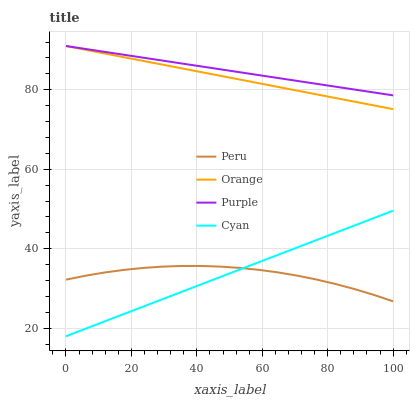Does Peru have the minimum area under the curve?
Answer yes or no. Yes. Does Purple have the maximum area under the curve?
Answer yes or no. Yes. Does Purple have the minimum area under the curve?
Answer yes or no. No. Does Peru have the maximum area under the curve?
Answer yes or no. No. Is Cyan the smoothest?
Answer yes or no. Yes. Is Peru the roughest?
Answer yes or no. Yes. Is Purple the smoothest?
Answer yes or no. No. Is Purple the roughest?
Answer yes or no. No. Does Cyan have the lowest value?
Answer yes or no. Yes. Does Peru have the lowest value?
Answer yes or no. No. Does Purple have the highest value?
Answer yes or no. Yes. Does Peru have the highest value?
Answer yes or no. No. Is Peru less than Orange?
Answer yes or no. Yes. Is Purple greater than Cyan?
Answer yes or no. Yes. Does Purple intersect Orange?
Answer yes or no. Yes. Is Purple less than Orange?
Answer yes or no. No. Is Purple greater than Orange?
Answer yes or no. No. Does Peru intersect Orange?
Answer yes or no. No. 